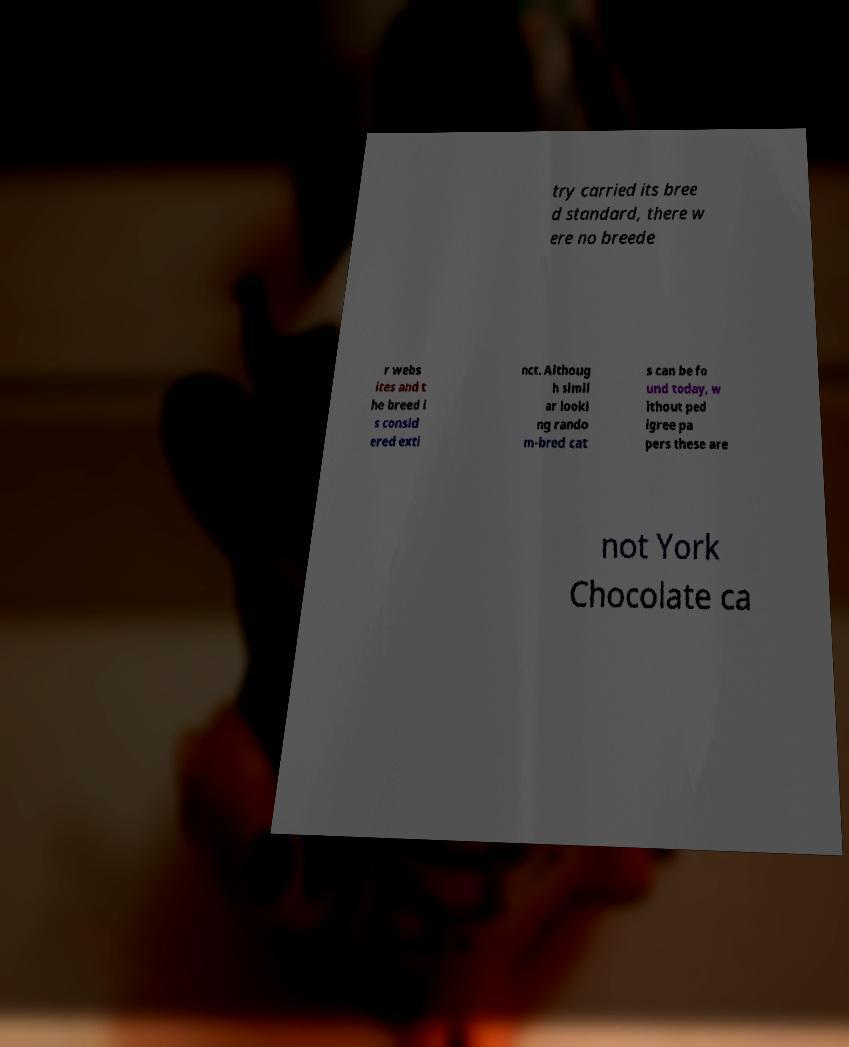For documentation purposes, I need the text within this image transcribed. Could you provide that? try carried its bree d standard, there w ere no breede r webs ites and t he breed i s consid ered exti nct. Althoug h simil ar looki ng rando m-bred cat s can be fo und today, w ithout ped igree pa pers these are not York Chocolate ca 